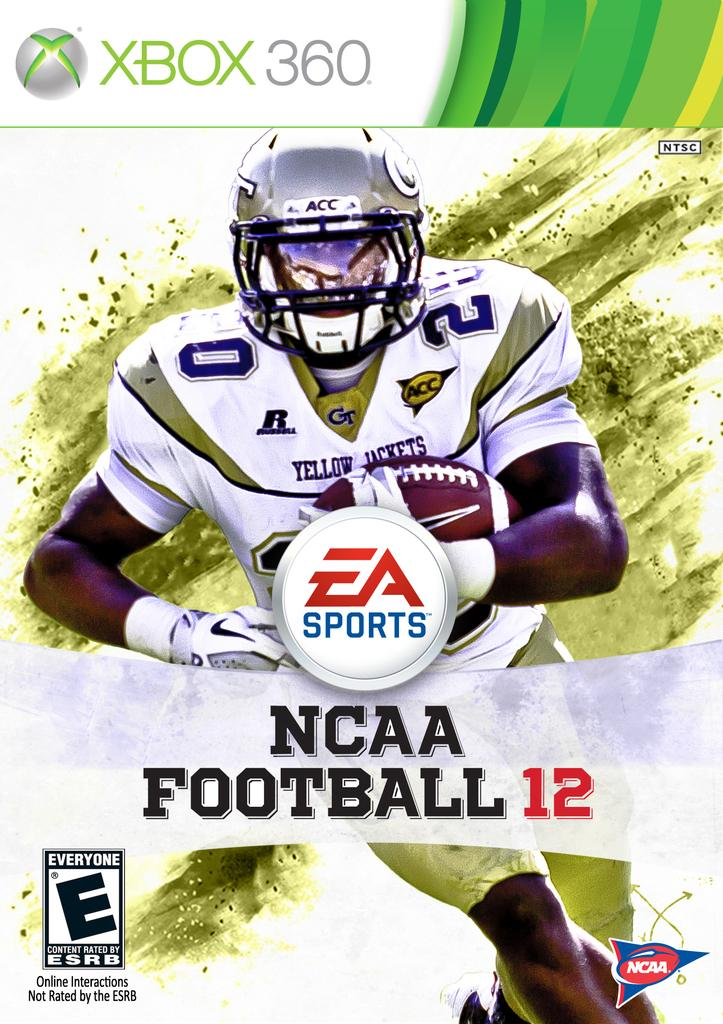What is the main subject of the image? There is a person in the image. What is the person holding? The person is holding a rugby ball. What else can be seen in the image besides the person and the rugby ball? There is text in the middle of the image and text above the middle text. What is the price of the mom's sister in the image? There is no mention of a mom or sister in the image, and therefore no price can be determined. 